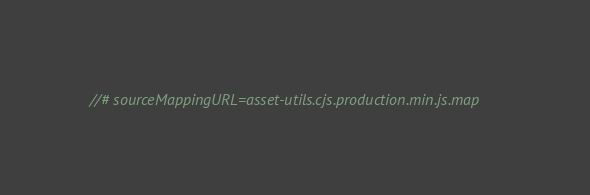Convert code to text. <code><loc_0><loc_0><loc_500><loc_500><_JavaScript_>//# sourceMappingURL=asset-utils.cjs.production.min.js.map
</code> 